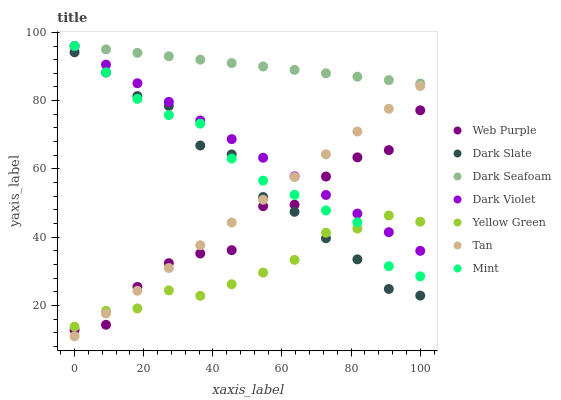Does Yellow Green have the minimum area under the curve?
Answer yes or no. Yes. Does Dark Seafoam have the maximum area under the curve?
Answer yes or no. Yes. Does Dark Violet have the minimum area under the curve?
Answer yes or no. No. Does Dark Violet have the maximum area under the curve?
Answer yes or no. No. Is Dark Violet the smoothest?
Answer yes or no. Yes. Is Web Purple the roughest?
Answer yes or no. Yes. Is Dark Seafoam the smoothest?
Answer yes or no. No. Is Dark Seafoam the roughest?
Answer yes or no. No. Does Tan have the lowest value?
Answer yes or no. Yes. Does Dark Violet have the lowest value?
Answer yes or no. No. Does Mint have the highest value?
Answer yes or no. Yes. Does Dark Slate have the highest value?
Answer yes or no. No. Is Dark Slate less than Dark Violet?
Answer yes or no. Yes. Is Dark Seafoam greater than Web Purple?
Answer yes or no. Yes. Does Tan intersect Mint?
Answer yes or no. Yes. Is Tan less than Mint?
Answer yes or no. No. Is Tan greater than Mint?
Answer yes or no. No. Does Dark Slate intersect Dark Violet?
Answer yes or no. No. 